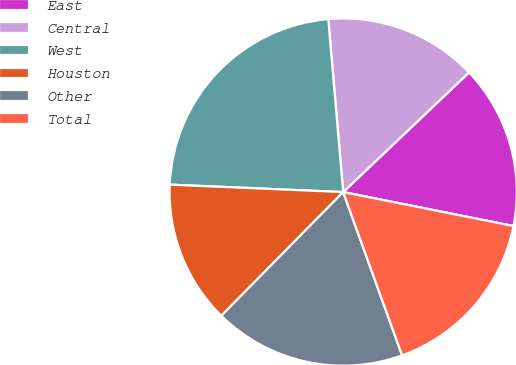Convert chart. <chart><loc_0><loc_0><loc_500><loc_500><pie_chart><fcel>East<fcel>Central<fcel>West<fcel>Houston<fcel>Other<fcel>Total<nl><fcel>15.23%<fcel>14.27%<fcel>22.95%<fcel>13.3%<fcel>17.89%<fcel>16.36%<nl></chart> 